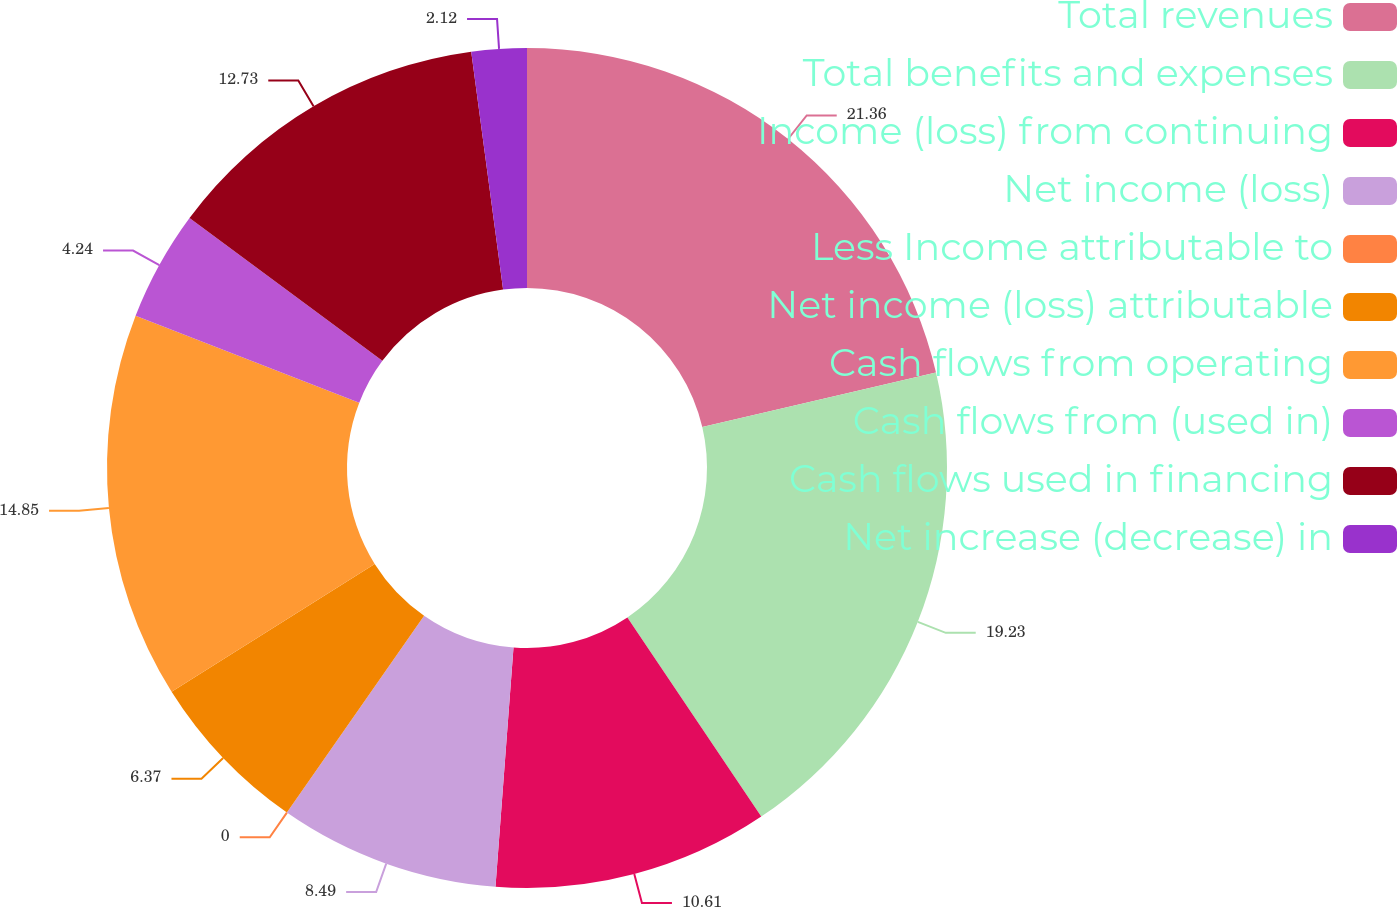Convert chart. <chart><loc_0><loc_0><loc_500><loc_500><pie_chart><fcel>Total revenues<fcel>Total benefits and expenses<fcel>Income (loss) from continuing<fcel>Net income (loss)<fcel>Less Income attributable to<fcel>Net income (loss) attributable<fcel>Cash flows from operating<fcel>Cash flows from (used in)<fcel>Cash flows used in financing<fcel>Net increase (decrease) in<nl><fcel>21.35%<fcel>19.23%<fcel>10.61%<fcel>8.49%<fcel>0.0%<fcel>6.37%<fcel>14.85%<fcel>4.24%<fcel>12.73%<fcel>2.12%<nl></chart> 